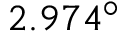<formula> <loc_0><loc_0><loc_500><loc_500>2 . 9 7 4 ^ { \circ }</formula> 